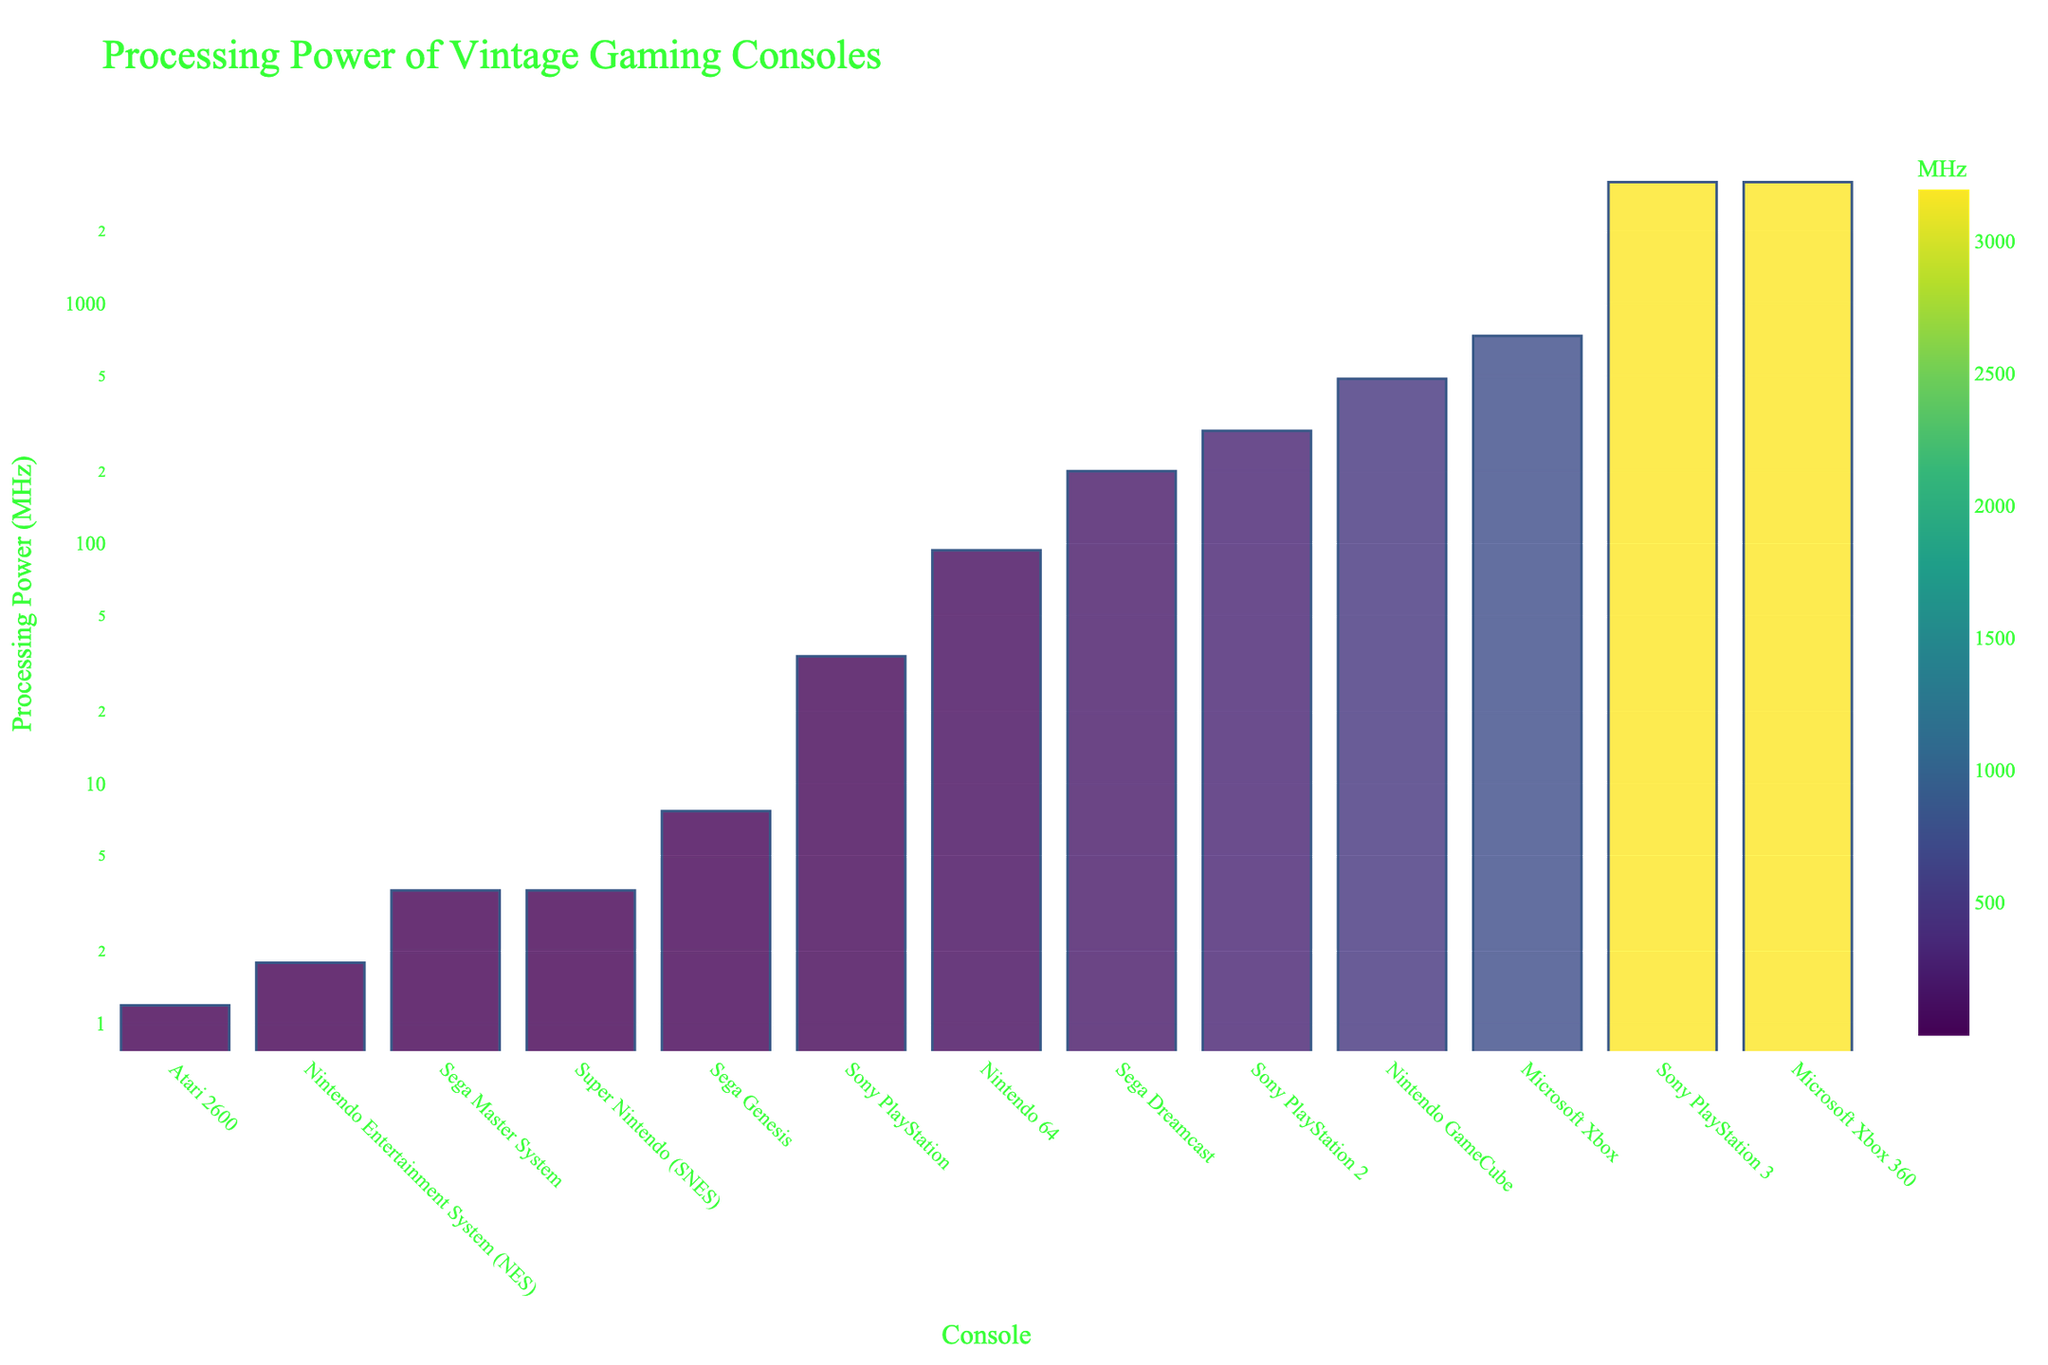Which console has the highest processing power? By looking at the y-axis values in the bar chart, the console with the tallest bar has the highest processing power. The tallest bar belongs to the Sony PlayStation 3, which has a processing power of 3200 MHz.
Answer: Sony PlayStation 3 Which generation console has a processing power greater than 1000 MHz but less than 4000 MHz? First, identify the bars with y-axis values (processing power) between 1000 MHz and 4000 MHz. The three consoles in this range are the Sony PlayStation 3, Microsoft Xbox 360, and Microsoft Xbox. All of these bars have values fitting in this range.
Answer: Sony PlayStation 3, Microsoft Xbox 360, Microsoft Xbox How does the processing power of the Nintendo 64 compare to that of the Sega Dreamcast? To compare, locate the bars for the Nintendo 64 and the Sega Dreamcast. The bar for the Sega Dreamcast is taller than that of the Nintendo 64. The Sega Dreamcast has a processing power of 200 MHz, whereas the Nintendo 64 has 93.75 MHz.
Answer: The Sega Dreamcast has a higher processing power Which console between the Atari 2600 and Sega Master System has a lower processing power? By comparing the heights of the bars for the Atari 2600 and the Sega Master System, we see that the bar for the Atari 2600 is shorter. The Atari 2600 has a processing power of 1.19 MHz, while the Sega Master System has 3.58 MHz.
Answer: Atari 2600 What is the difference in processing power between the Sega Genesis and Sony PlayStation? First, find the heights of bars for both the Sega Genesis and Sony PlayStation. The Sega Genesis has a processing power of 7.67 MHz, and the Sony PlayStation has 33.87 MHz. The difference is 33.87 - 7.67.
Answer: 26.2 MHz Which consoles have processing power below 10 MHz? Look for bars whose height corresponds to y-axis values below 10 MHz. These are Atari 2600 (1.19 MHz), Nintendo Entertainment System (1.79 MHz), Sega Master System (3.58 MHz), Super Nintendo (3.58 MHz), and Sega Genesis (7.67 MHz).
Answer: Atari 2600, Nintendo Entertainment System, Sega Master System, Super Nintendo, Sega Genesis What is the average processing power of the Sega consoles shown in the figure? Identify the processing powers of all Sega consoles: Sega Master System (3.58 MHz), Sega Genesis (7.67 MHz), Sega Dreamcast (200 MHz). Calculate the average: (3.58 + 7.67 + 200) / 3.
Answer: 70.42 MHz What is the approximate ratio of processing power between the Sony PlayStation 2 and the Nintendo GameCube? Find the heights of the bars for these consoles: Sony PlayStation 2 (294.91 MHz) and Nintendo GameCube (485 MHz). The ratio is approximately 294.91:485 which simplifies to around 0.61:1.
Answer: 0.61:1 Which three consoles fall in the middle range of processing power values? Sort the consoles by their processing power values and select the middle three: Sega Genesis (7.67 MHz), Sony PlayStation (33.87 MHz), and Nintendo 64 (93.75 MHz). These represent the middle range between the lowest and highest values.
Answer: Sega Genesis, Sony PlayStation, Nintendo 64 